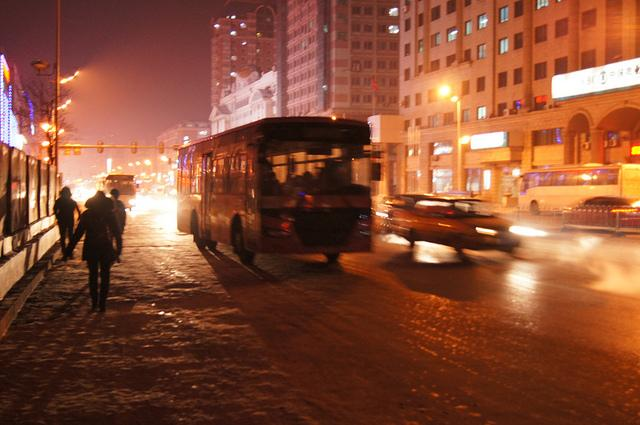What hazard appears to be occurring on the road? Please explain your reasoning. slippery. The road is currently slippery. 